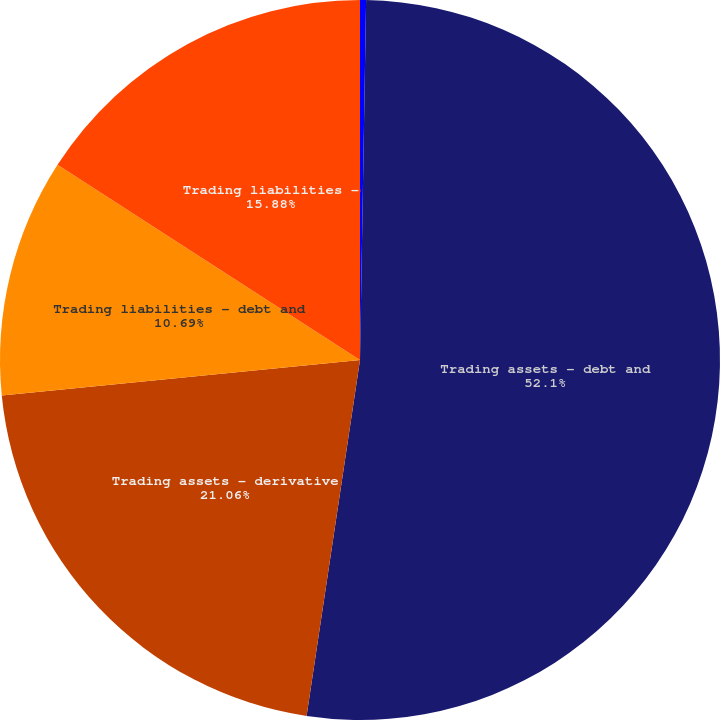Convert chart. <chart><loc_0><loc_0><loc_500><loc_500><pie_chart><fcel>Year ended December 31 (in<fcel>Trading assets - debt and<fcel>Trading assets - derivative<fcel>Trading liabilities - debt and<fcel>Trading liabilities -<nl><fcel>0.27%<fcel>52.1%<fcel>21.06%<fcel>10.69%<fcel>15.88%<nl></chart> 